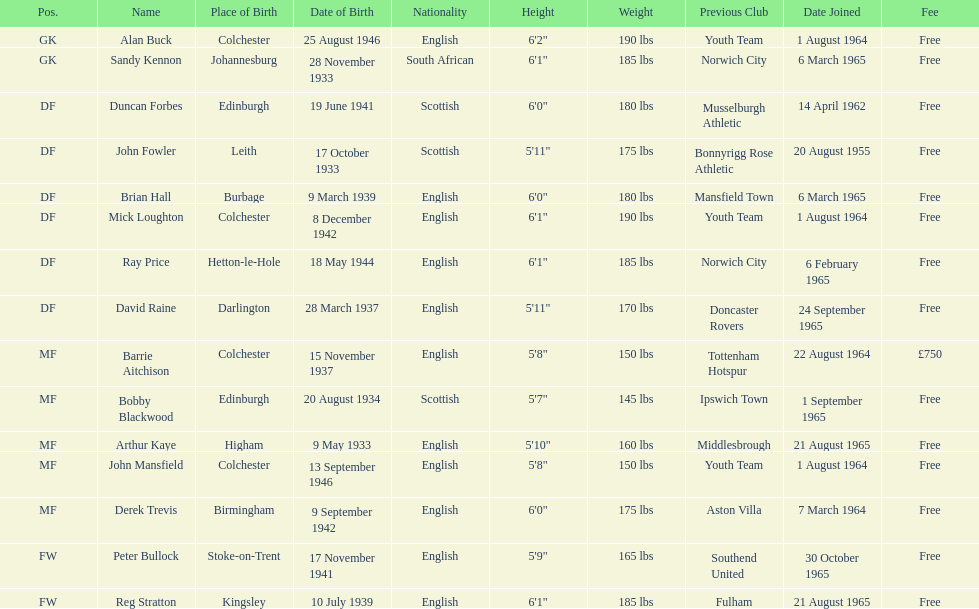Is arthur kaye older or younger than brian hill? Older. 